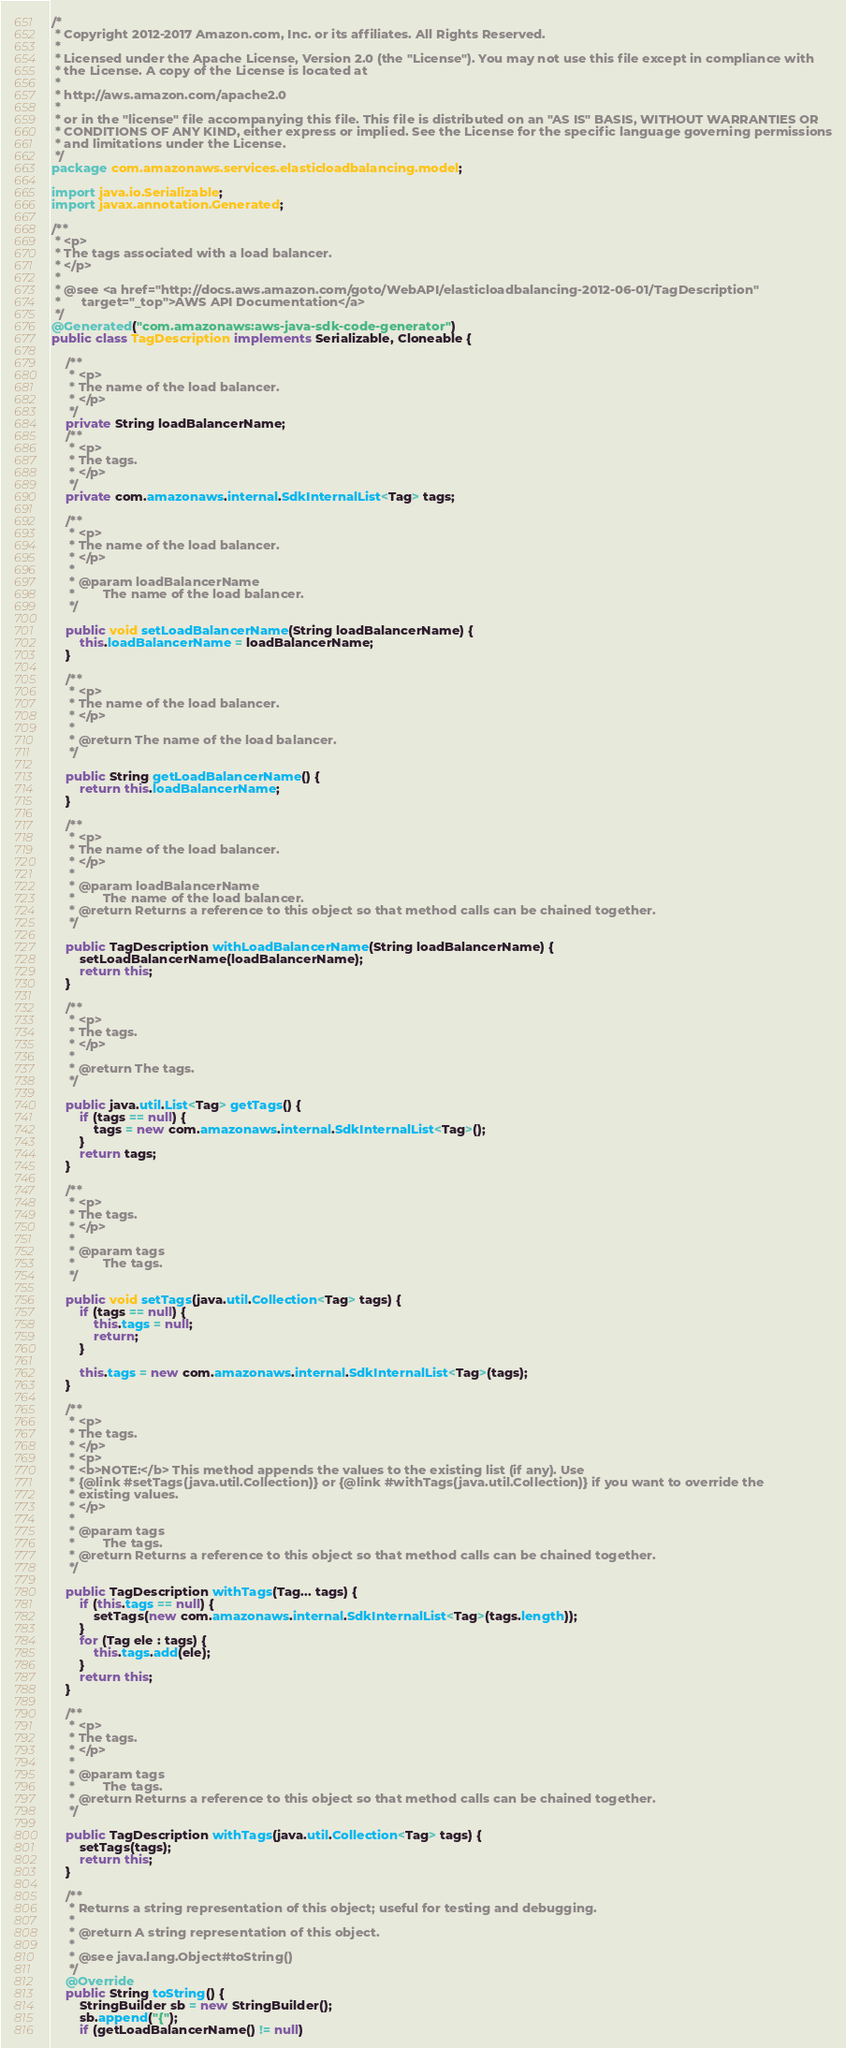Convert code to text. <code><loc_0><loc_0><loc_500><loc_500><_Java_>/*
 * Copyright 2012-2017 Amazon.com, Inc. or its affiliates. All Rights Reserved.
 * 
 * Licensed under the Apache License, Version 2.0 (the "License"). You may not use this file except in compliance with
 * the License. A copy of the License is located at
 * 
 * http://aws.amazon.com/apache2.0
 * 
 * or in the "license" file accompanying this file. This file is distributed on an "AS IS" BASIS, WITHOUT WARRANTIES OR
 * CONDITIONS OF ANY KIND, either express or implied. See the License for the specific language governing permissions
 * and limitations under the License.
 */
package com.amazonaws.services.elasticloadbalancing.model;

import java.io.Serializable;
import javax.annotation.Generated;

/**
 * <p>
 * The tags associated with a load balancer.
 * </p>
 * 
 * @see <a href="http://docs.aws.amazon.com/goto/WebAPI/elasticloadbalancing-2012-06-01/TagDescription"
 *      target="_top">AWS API Documentation</a>
 */
@Generated("com.amazonaws:aws-java-sdk-code-generator")
public class TagDescription implements Serializable, Cloneable {

    /**
     * <p>
     * The name of the load balancer.
     * </p>
     */
    private String loadBalancerName;
    /**
     * <p>
     * The tags.
     * </p>
     */
    private com.amazonaws.internal.SdkInternalList<Tag> tags;

    /**
     * <p>
     * The name of the load balancer.
     * </p>
     * 
     * @param loadBalancerName
     *        The name of the load balancer.
     */

    public void setLoadBalancerName(String loadBalancerName) {
        this.loadBalancerName = loadBalancerName;
    }

    /**
     * <p>
     * The name of the load balancer.
     * </p>
     * 
     * @return The name of the load balancer.
     */

    public String getLoadBalancerName() {
        return this.loadBalancerName;
    }

    /**
     * <p>
     * The name of the load balancer.
     * </p>
     * 
     * @param loadBalancerName
     *        The name of the load balancer.
     * @return Returns a reference to this object so that method calls can be chained together.
     */

    public TagDescription withLoadBalancerName(String loadBalancerName) {
        setLoadBalancerName(loadBalancerName);
        return this;
    }

    /**
     * <p>
     * The tags.
     * </p>
     * 
     * @return The tags.
     */

    public java.util.List<Tag> getTags() {
        if (tags == null) {
            tags = new com.amazonaws.internal.SdkInternalList<Tag>();
        }
        return tags;
    }

    /**
     * <p>
     * The tags.
     * </p>
     * 
     * @param tags
     *        The tags.
     */

    public void setTags(java.util.Collection<Tag> tags) {
        if (tags == null) {
            this.tags = null;
            return;
        }

        this.tags = new com.amazonaws.internal.SdkInternalList<Tag>(tags);
    }

    /**
     * <p>
     * The tags.
     * </p>
     * <p>
     * <b>NOTE:</b> This method appends the values to the existing list (if any). Use
     * {@link #setTags(java.util.Collection)} or {@link #withTags(java.util.Collection)} if you want to override the
     * existing values.
     * </p>
     * 
     * @param tags
     *        The tags.
     * @return Returns a reference to this object so that method calls can be chained together.
     */

    public TagDescription withTags(Tag... tags) {
        if (this.tags == null) {
            setTags(new com.amazonaws.internal.SdkInternalList<Tag>(tags.length));
        }
        for (Tag ele : tags) {
            this.tags.add(ele);
        }
        return this;
    }

    /**
     * <p>
     * The tags.
     * </p>
     * 
     * @param tags
     *        The tags.
     * @return Returns a reference to this object so that method calls can be chained together.
     */

    public TagDescription withTags(java.util.Collection<Tag> tags) {
        setTags(tags);
        return this;
    }

    /**
     * Returns a string representation of this object; useful for testing and debugging.
     *
     * @return A string representation of this object.
     *
     * @see java.lang.Object#toString()
     */
    @Override
    public String toString() {
        StringBuilder sb = new StringBuilder();
        sb.append("{");
        if (getLoadBalancerName() != null)</code> 